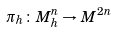Convert formula to latex. <formula><loc_0><loc_0><loc_500><loc_500>\pi _ { h } \colon M _ { h } ^ { n } \rightarrow M ^ { 2 n }</formula> 